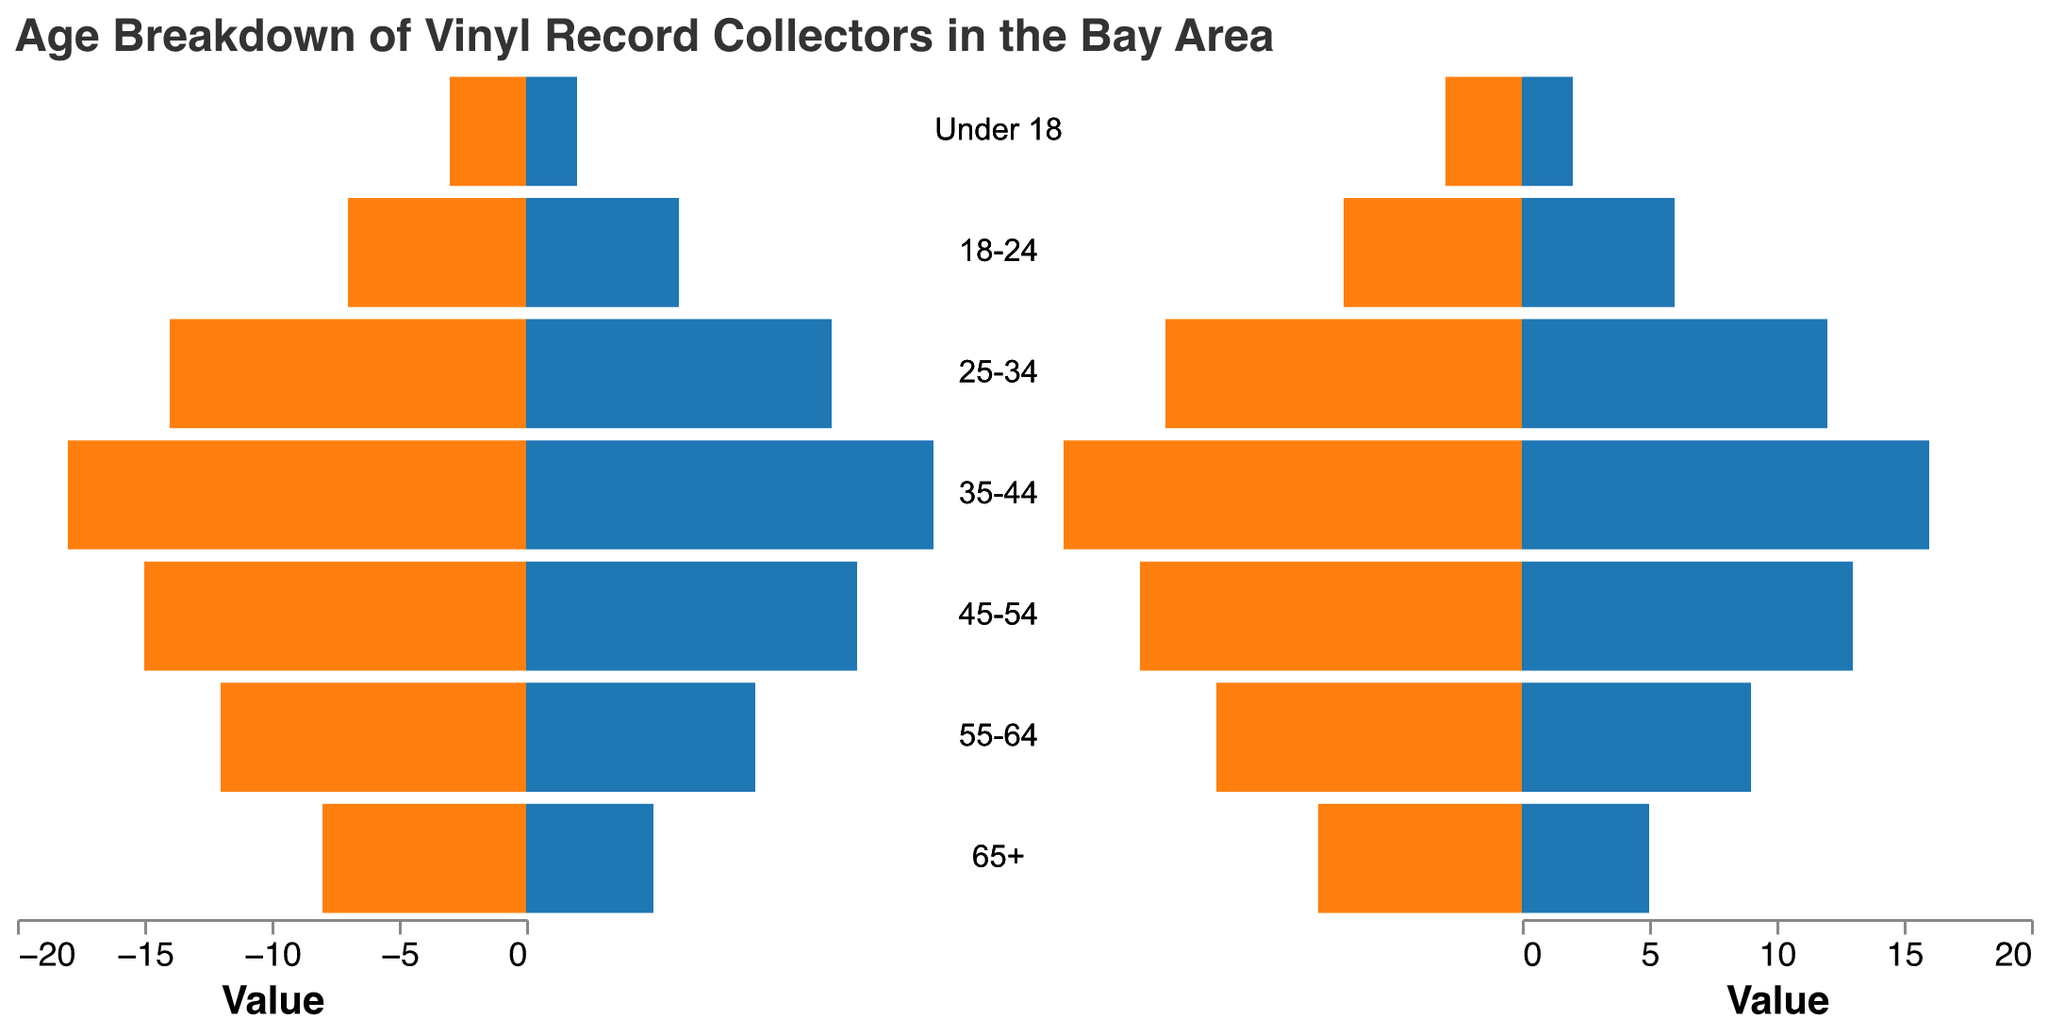What is the title of the figure? The title is displayed at the top of the figure in a larger font.
Answer: Age Breakdown of Vinyl Record Collectors in the Bay Area How many age groups are represented in the figure? By counting the distinct age group labels on the y-axis, we see seven age groups.
Answer: 7 Which age group has the highest number of male vinyl record collectors? Look at the lengths of the blue bars on the left side; the longest bar represents males in the 35-44 age group.
Answer: 35-44 What is the total number of female vinyl record collectors aged between 18 and 34? Sum the values for females in the age groups "18-24" and "25-34": 6 + 12.
Answer: 18 How does the number of female collectors aged 65+ compare to those aged 18-24? Compare the orange bar lengths for the age groups "65+" and "18-24". For the "65+" group, there are 5 females, while for the "18-24" group, there are 6 females.
Answer: 65+ has fewer What is the total number of vinyl record collectors in the 45-54 age group? Add the number of male and female collectors in the 45-54 age group: 15 (male) + 13 (female).
Answer: 28 Which gender has more collectors in the 25-34 age group? Compare the lengths of the bars for the "25-34" age group; the bar for males is longer than the one for females, with values of 14 (male) and 12 (female).
Answer: Male What is the difference in the number of male and female collectors in the 35-44 age group? Subtract the number of female collectors from the number of male collectors in the 35-44 age group: 18 (male) - 16 (female).
Answer: 2 Which age group has the smallest total number of collectors? By summing the male and female counts for each age group, the group "Under 18" has the smallest total: 3 (male) + 2 (female).
Answer: Under 18 How many more males than females are there in the 55-64 age group? Subtract the number of female collectors from the number of male collectors in the 55-64 age group: 12 (male) - 9 (female).
Answer: 3 